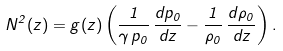<formula> <loc_0><loc_0><loc_500><loc_500>N ^ { 2 } ( z ) = g ( z ) \left ( \frac { 1 } { \gamma \, p _ { 0 } } \, \frac { d p _ { 0 } } { d z } - \frac { 1 } { \rho _ { 0 } } \, \frac { d \rho _ { 0 } } { d z } \right ) .</formula> 